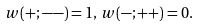Convert formula to latex. <formula><loc_0><loc_0><loc_500><loc_500>w ( + ; - - ) = 1 , \, w ( - ; + + ) = 0 .</formula> 